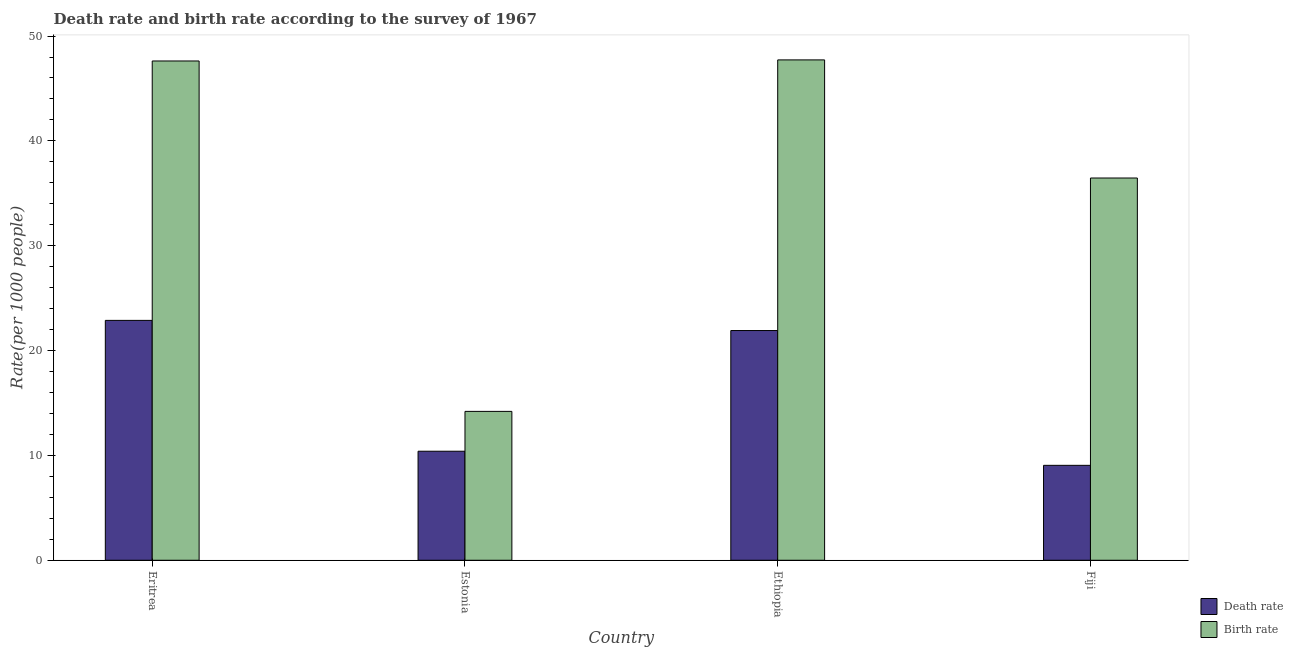How many different coloured bars are there?
Ensure brevity in your answer.  2. Are the number of bars on each tick of the X-axis equal?
Provide a succinct answer. Yes. How many bars are there on the 3rd tick from the left?
Your answer should be very brief. 2. How many bars are there on the 2nd tick from the right?
Your response must be concise. 2. What is the label of the 1st group of bars from the left?
Your response must be concise. Eritrea. What is the birth rate in Fiji?
Give a very brief answer. 36.46. Across all countries, what is the maximum death rate?
Give a very brief answer. 22.88. Across all countries, what is the minimum death rate?
Make the answer very short. 9.05. In which country was the birth rate maximum?
Provide a succinct answer. Ethiopia. In which country was the death rate minimum?
Give a very brief answer. Fiji. What is the total birth rate in the graph?
Your response must be concise. 146. What is the difference between the death rate in Ethiopia and that in Fiji?
Your answer should be compact. 12.86. What is the difference between the birth rate in Fiji and the death rate in Eritrea?
Give a very brief answer. 13.58. What is the average birth rate per country?
Ensure brevity in your answer.  36.5. What is the difference between the death rate and birth rate in Ethiopia?
Provide a short and direct response. -25.81. In how many countries, is the birth rate greater than 44 ?
Your answer should be very brief. 2. What is the ratio of the birth rate in Ethiopia to that in Fiji?
Provide a short and direct response. 1.31. Is the difference between the birth rate in Eritrea and Ethiopia greater than the difference between the death rate in Eritrea and Ethiopia?
Make the answer very short. No. What is the difference between the highest and the second highest death rate?
Make the answer very short. 0.97. What is the difference between the highest and the lowest birth rate?
Give a very brief answer. 33.53. Is the sum of the death rate in Eritrea and Estonia greater than the maximum birth rate across all countries?
Offer a very short reply. No. What does the 1st bar from the left in Eritrea represents?
Your response must be concise. Death rate. What does the 2nd bar from the right in Estonia represents?
Your answer should be very brief. Death rate. Are all the bars in the graph horizontal?
Make the answer very short. No. How many countries are there in the graph?
Give a very brief answer. 4. Are the values on the major ticks of Y-axis written in scientific E-notation?
Provide a succinct answer. No. Does the graph contain any zero values?
Your answer should be very brief. No. Does the graph contain grids?
Your response must be concise. No. Where does the legend appear in the graph?
Your answer should be very brief. Bottom right. How are the legend labels stacked?
Your answer should be very brief. Vertical. What is the title of the graph?
Give a very brief answer. Death rate and birth rate according to the survey of 1967. Does "Transport services" appear as one of the legend labels in the graph?
Your answer should be very brief. No. What is the label or title of the Y-axis?
Your answer should be very brief. Rate(per 1000 people). What is the Rate(per 1000 people) of Death rate in Eritrea?
Ensure brevity in your answer.  22.88. What is the Rate(per 1000 people) of Birth rate in Eritrea?
Provide a short and direct response. 47.62. What is the Rate(per 1000 people) in Death rate in Estonia?
Offer a terse response. 10.4. What is the Rate(per 1000 people) in Death rate in Ethiopia?
Give a very brief answer. 21.91. What is the Rate(per 1000 people) in Birth rate in Ethiopia?
Offer a terse response. 47.73. What is the Rate(per 1000 people) in Death rate in Fiji?
Your answer should be compact. 9.05. What is the Rate(per 1000 people) in Birth rate in Fiji?
Keep it short and to the point. 36.46. Across all countries, what is the maximum Rate(per 1000 people) in Death rate?
Offer a very short reply. 22.88. Across all countries, what is the maximum Rate(per 1000 people) in Birth rate?
Provide a succinct answer. 47.73. Across all countries, what is the minimum Rate(per 1000 people) in Death rate?
Offer a very short reply. 9.05. What is the total Rate(per 1000 people) of Death rate in the graph?
Give a very brief answer. 64.25. What is the total Rate(per 1000 people) of Birth rate in the graph?
Your answer should be very brief. 146. What is the difference between the Rate(per 1000 people) in Death rate in Eritrea and that in Estonia?
Provide a succinct answer. 12.48. What is the difference between the Rate(per 1000 people) of Birth rate in Eritrea and that in Estonia?
Provide a short and direct response. 33.42. What is the difference between the Rate(per 1000 people) of Death rate in Eritrea and that in Ethiopia?
Give a very brief answer. 0.97. What is the difference between the Rate(per 1000 people) of Birth rate in Eritrea and that in Ethiopia?
Offer a very short reply. -0.1. What is the difference between the Rate(per 1000 people) of Death rate in Eritrea and that in Fiji?
Offer a terse response. 13.83. What is the difference between the Rate(per 1000 people) of Birth rate in Eritrea and that in Fiji?
Provide a short and direct response. 11.16. What is the difference between the Rate(per 1000 people) of Death rate in Estonia and that in Ethiopia?
Ensure brevity in your answer.  -11.51. What is the difference between the Rate(per 1000 people) in Birth rate in Estonia and that in Ethiopia?
Offer a terse response. -33.52. What is the difference between the Rate(per 1000 people) in Death rate in Estonia and that in Fiji?
Your answer should be very brief. 1.35. What is the difference between the Rate(per 1000 people) in Birth rate in Estonia and that in Fiji?
Provide a short and direct response. -22.26. What is the difference between the Rate(per 1000 people) of Death rate in Ethiopia and that in Fiji?
Keep it short and to the point. 12.86. What is the difference between the Rate(per 1000 people) in Birth rate in Ethiopia and that in Fiji?
Offer a very short reply. 11.27. What is the difference between the Rate(per 1000 people) of Death rate in Eritrea and the Rate(per 1000 people) of Birth rate in Estonia?
Your response must be concise. 8.68. What is the difference between the Rate(per 1000 people) in Death rate in Eritrea and the Rate(per 1000 people) in Birth rate in Ethiopia?
Offer a terse response. -24.84. What is the difference between the Rate(per 1000 people) of Death rate in Eritrea and the Rate(per 1000 people) of Birth rate in Fiji?
Offer a very short reply. -13.58. What is the difference between the Rate(per 1000 people) in Death rate in Estonia and the Rate(per 1000 people) in Birth rate in Ethiopia?
Offer a terse response. -37.33. What is the difference between the Rate(per 1000 people) in Death rate in Estonia and the Rate(per 1000 people) in Birth rate in Fiji?
Offer a very short reply. -26.06. What is the difference between the Rate(per 1000 people) in Death rate in Ethiopia and the Rate(per 1000 people) in Birth rate in Fiji?
Keep it short and to the point. -14.55. What is the average Rate(per 1000 people) of Death rate per country?
Your answer should be compact. 16.06. What is the average Rate(per 1000 people) of Birth rate per country?
Provide a short and direct response. 36.5. What is the difference between the Rate(per 1000 people) of Death rate and Rate(per 1000 people) of Birth rate in Eritrea?
Provide a short and direct response. -24.74. What is the difference between the Rate(per 1000 people) of Death rate and Rate(per 1000 people) of Birth rate in Ethiopia?
Your answer should be very brief. -25.81. What is the difference between the Rate(per 1000 people) in Death rate and Rate(per 1000 people) in Birth rate in Fiji?
Your answer should be very brief. -27.41. What is the ratio of the Rate(per 1000 people) of Death rate in Eritrea to that in Estonia?
Your response must be concise. 2.2. What is the ratio of the Rate(per 1000 people) of Birth rate in Eritrea to that in Estonia?
Ensure brevity in your answer.  3.35. What is the ratio of the Rate(per 1000 people) of Death rate in Eritrea to that in Ethiopia?
Your answer should be very brief. 1.04. What is the ratio of the Rate(per 1000 people) in Death rate in Eritrea to that in Fiji?
Keep it short and to the point. 2.53. What is the ratio of the Rate(per 1000 people) in Birth rate in Eritrea to that in Fiji?
Ensure brevity in your answer.  1.31. What is the ratio of the Rate(per 1000 people) of Death rate in Estonia to that in Ethiopia?
Keep it short and to the point. 0.47. What is the ratio of the Rate(per 1000 people) of Birth rate in Estonia to that in Ethiopia?
Make the answer very short. 0.3. What is the ratio of the Rate(per 1000 people) of Death rate in Estonia to that in Fiji?
Make the answer very short. 1.15. What is the ratio of the Rate(per 1000 people) in Birth rate in Estonia to that in Fiji?
Offer a very short reply. 0.39. What is the ratio of the Rate(per 1000 people) in Death rate in Ethiopia to that in Fiji?
Provide a short and direct response. 2.42. What is the ratio of the Rate(per 1000 people) of Birth rate in Ethiopia to that in Fiji?
Your response must be concise. 1.31. What is the difference between the highest and the second highest Rate(per 1000 people) of Death rate?
Give a very brief answer. 0.97. What is the difference between the highest and the second highest Rate(per 1000 people) of Birth rate?
Give a very brief answer. 0.1. What is the difference between the highest and the lowest Rate(per 1000 people) in Death rate?
Your answer should be very brief. 13.83. What is the difference between the highest and the lowest Rate(per 1000 people) in Birth rate?
Offer a very short reply. 33.52. 